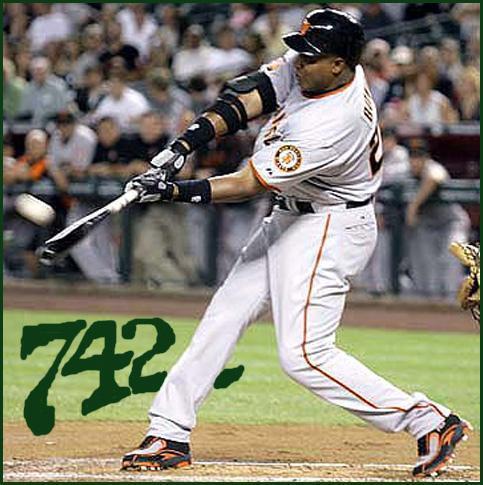How many people are in the picture?
Give a very brief answer. 5. 